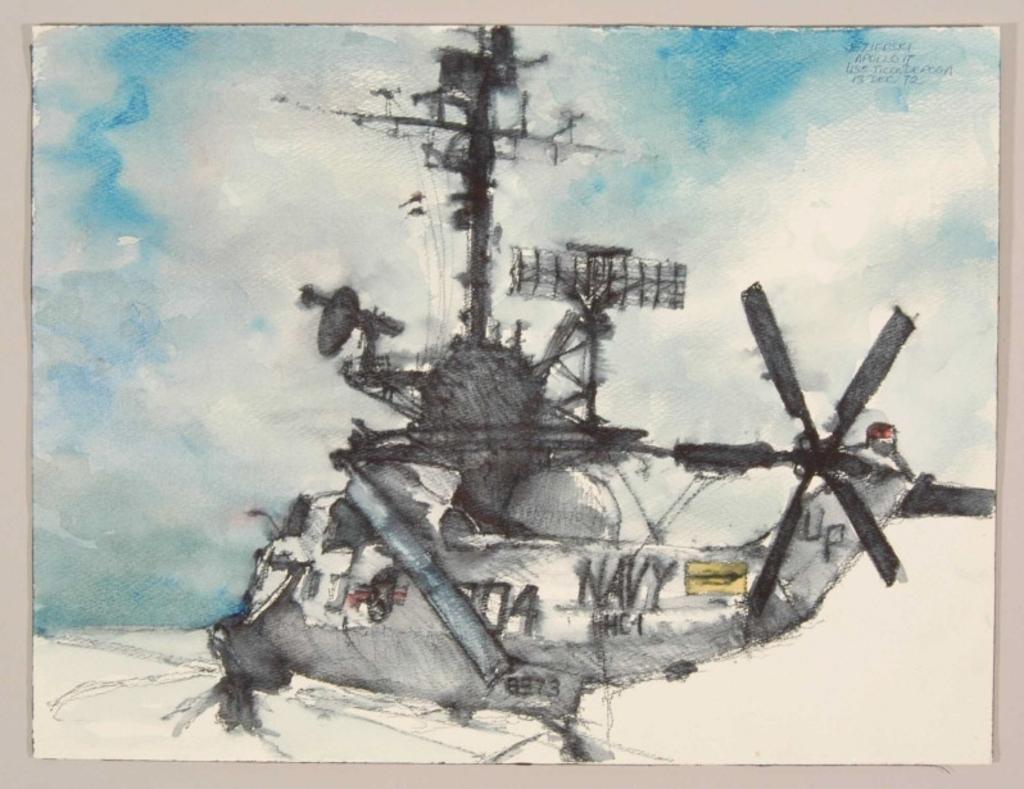Who does this aircraft belong to?
Your answer should be very brief. Navy. 